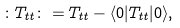<formula> <loc_0><loc_0><loc_500><loc_500>\colon T _ { t t } \colon = T _ { t t } - \langle 0 | T _ { t t } | 0 \rangle ,</formula> 